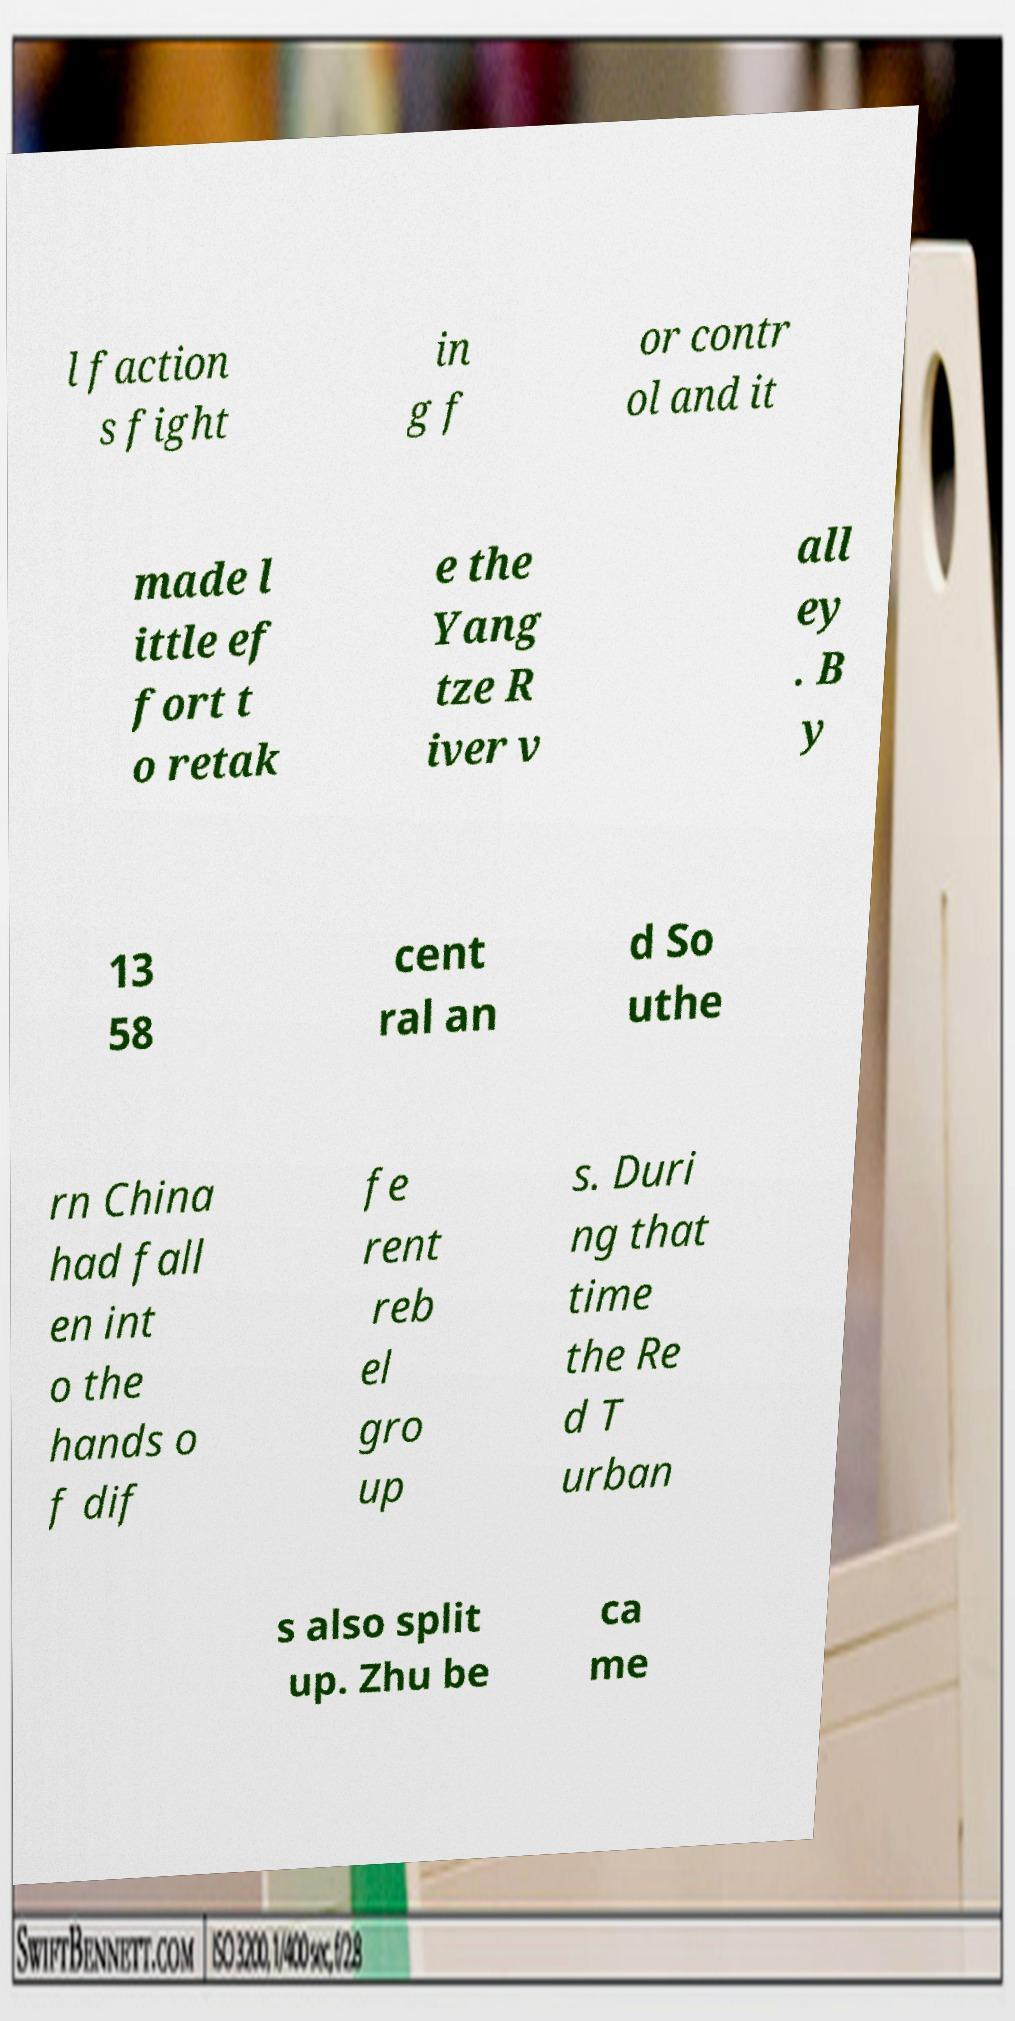There's text embedded in this image that I need extracted. Can you transcribe it verbatim? l faction s fight in g f or contr ol and it made l ittle ef fort t o retak e the Yang tze R iver v all ey . B y 13 58 cent ral an d So uthe rn China had fall en int o the hands o f dif fe rent reb el gro up s. Duri ng that time the Re d T urban s also split up. Zhu be ca me 